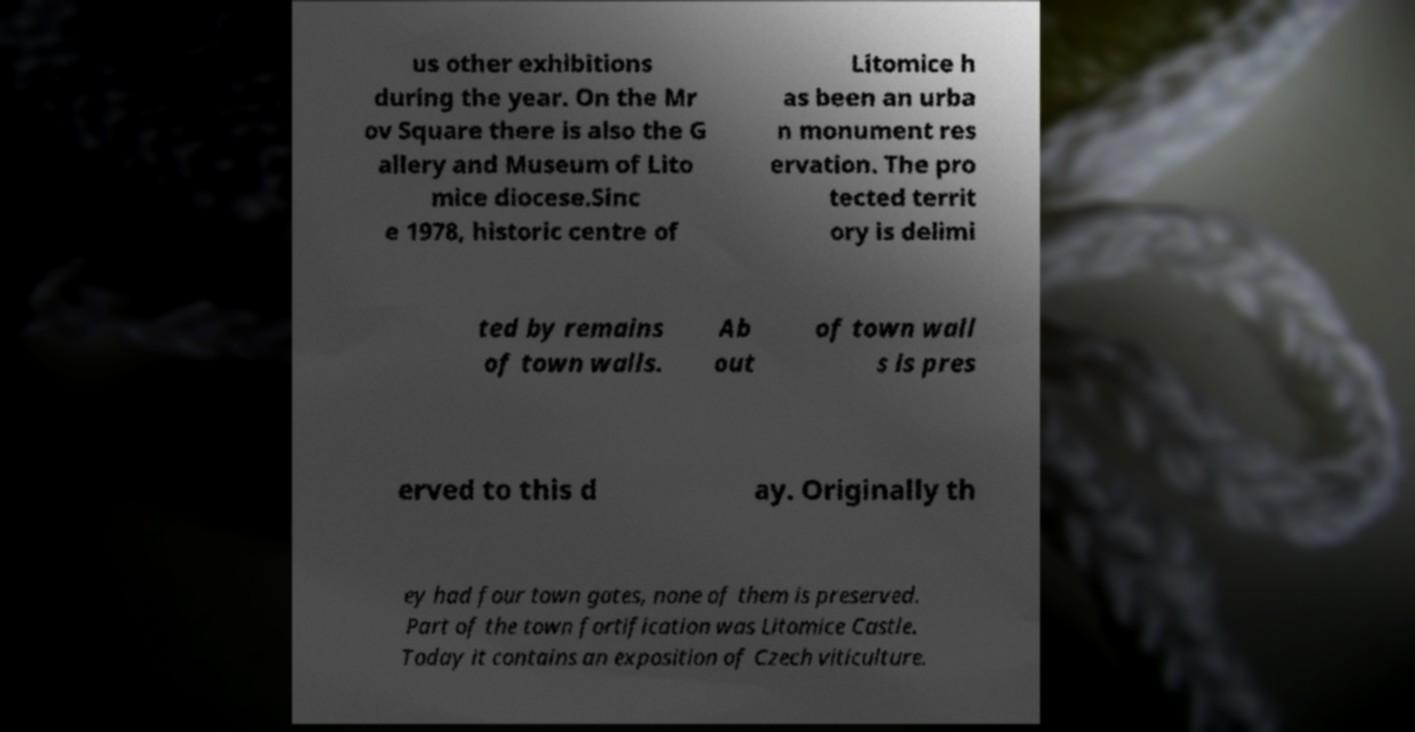For documentation purposes, I need the text within this image transcribed. Could you provide that? us other exhibitions during the year. On the Mr ov Square there is also the G allery and Museum of Lito mice diocese.Sinc e 1978, historic centre of Litomice h as been an urba n monument res ervation. The pro tected territ ory is delimi ted by remains of town walls. Ab out of town wall s is pres erved to this d ay. Originally th ey had four town gates, none of them is preserved. Part of the town fortification was Litomice Castle. Today it contains an exposition of Czech viticulture. 